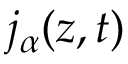Convert formula to latex. <formula><loc_0><loc_0><loc_500><loc_500>j _ { \alpha } ( z , t )</formula> 